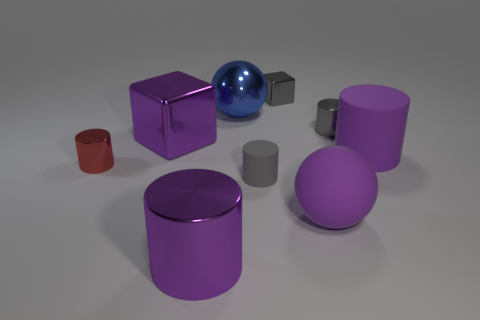There is a metal cylinder that is the same color as the large rubber cylinder; what size is it?
Provide a succinct answer. Large. There is a small matte object; is its color the same as the metallic cylinder that is right of the gray matte thing?
Your answer should be compact. Yes. There is a small shiny cylinder on the right side of the big metal block; does it have the same color as the tiny matte object?
Your answer should be compact. Yes. There is a tiny matte thing that is the same color as the tiny cube; what is its shape?
Ensure brevity in your answer.  Cylinder. Are there fewer small gray rubber objects than purple things?
Make the answer very short. Yes. There is a ball in front of the big ball that is behind the large purple metallic cube; what color is it?
Make the answer very short. Purple. There is a purple object that is the same shape as the blue shiny object; what is its material?
Ensure brevity in your answer.  Rubber. How many metal things are either gray cubes or tiny red blocks?
Provide a succinct answer. 1. Are the purple object that is left of the purple metallic cylinder and the purple cylinder that is to the right of the large purple metal cylinder made of the same material?
Provide a succinct answer. No. Are any red objects visible?
Ensure brevity in your answer.  Yes. 